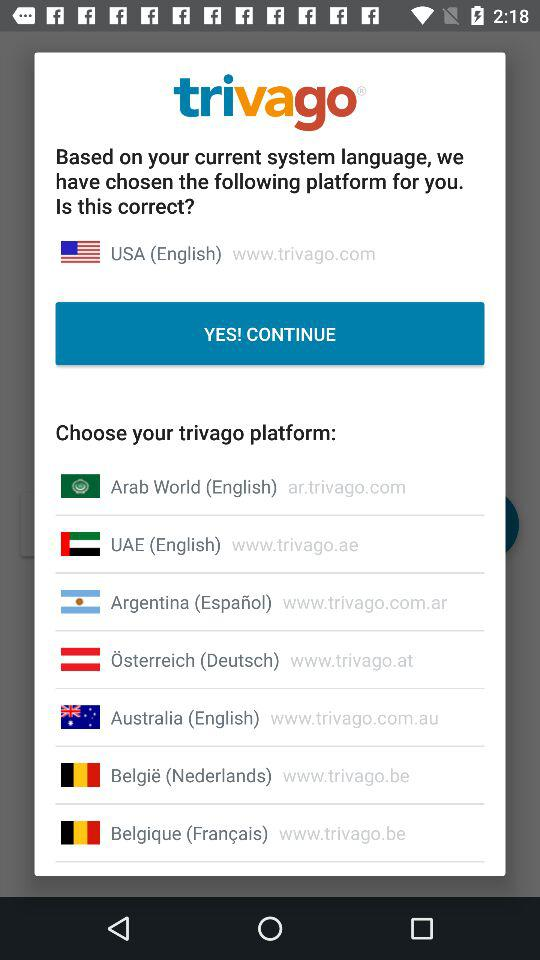Which country has been selected based on the current system's language? The country is USA. 